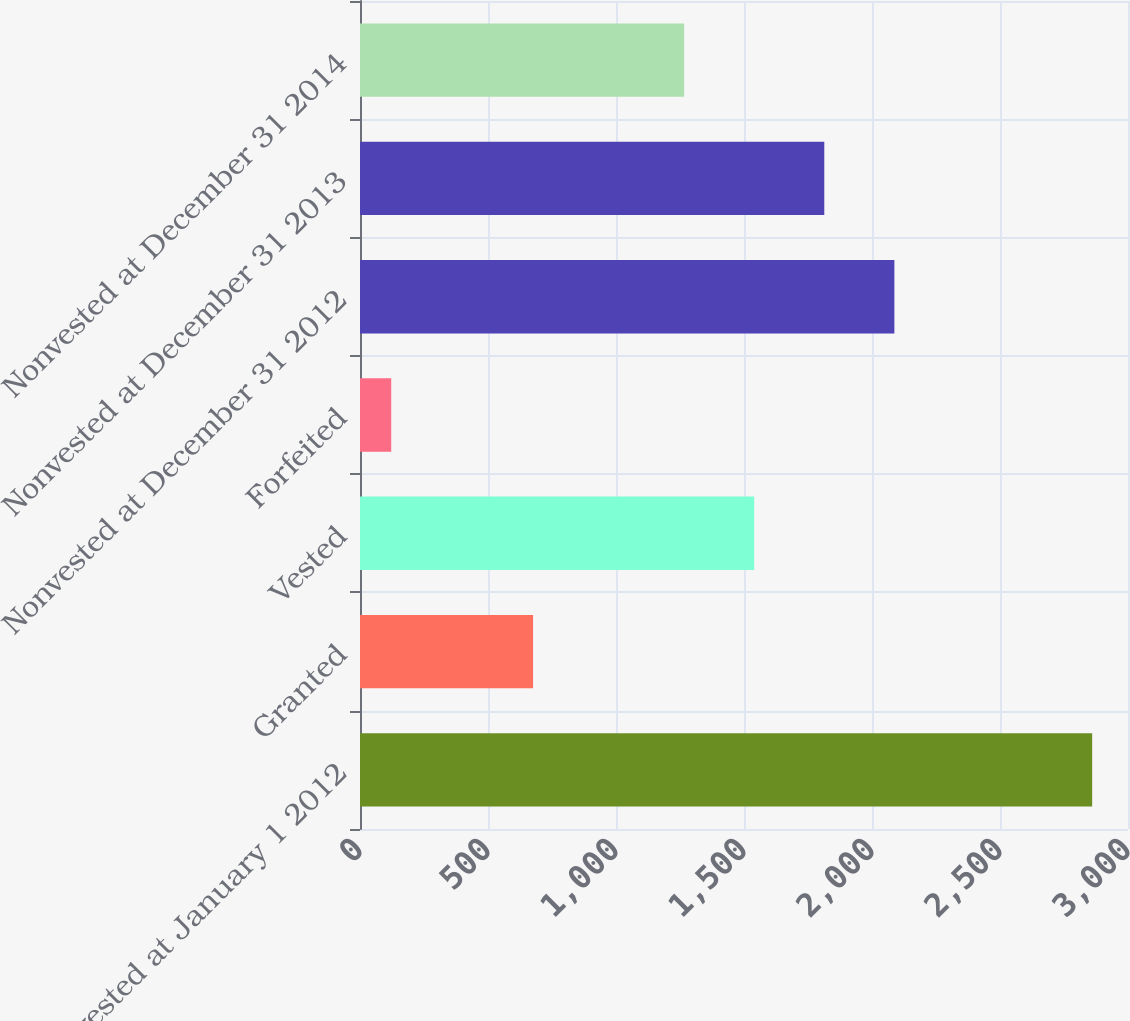<chart> <loc_0><loc_0><loc_500><loc_500><bar_chart><fcel>Nonvested at January 1 2012<fcel>Granted<fcel>Vested<fcel>Forfeited<fcel>Nonvested at December 31 2012<fcel>Nonvested at December 31 2013<fcel>Nonvested at December 31 2014<nl><fcel>2860<fcel>676<fcel>1539.8<fcel>122<fcel>2087.4<fcel>1813.6<fcel>1266<nl></chart> 